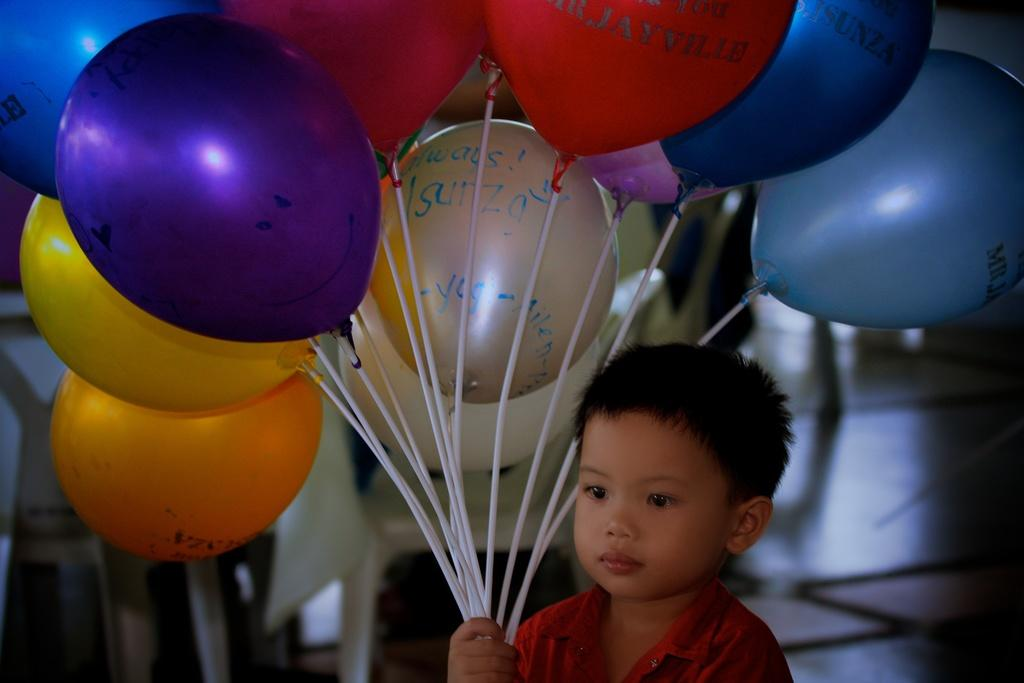Who is the main subject in the image? There is a boy in the image. What is the boy holding in the image? The boy is holding balloons. What can be seen in the background of the image? There are chairs in the background of the image. What type of marble is the boy playing with in the image? There is no marble present in the image; the boy is holding balloons. What kind of wren can be seen perched on the boy's shoulder in the image? There is no wren present in the image; the boy is holding balloons and there are chairs in the background. 